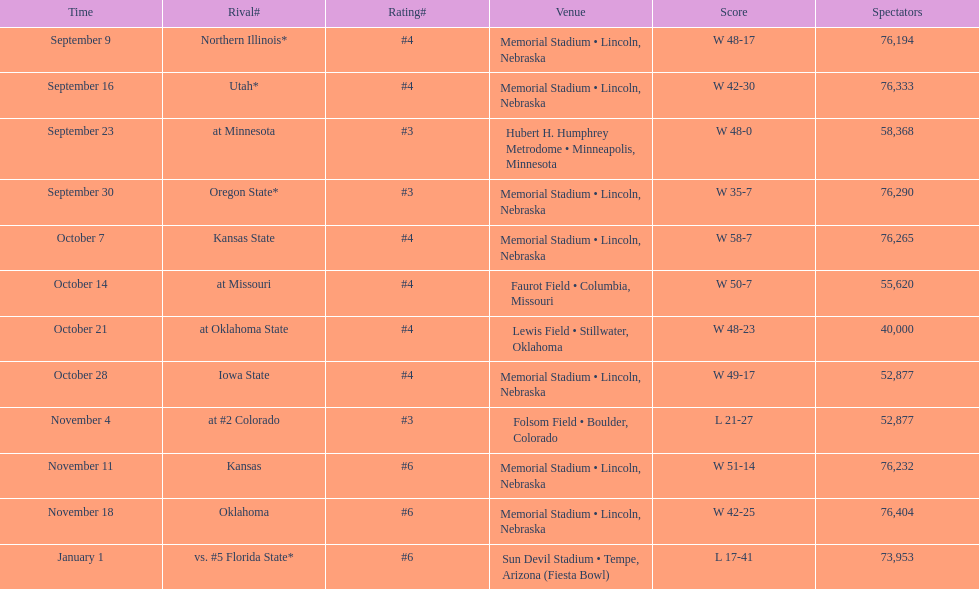What site at most is taken place? Memorial Stadium • Lincoln, Nebraska. 